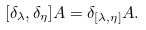<formula> <loc_0><loc_0><loc_500><loc_500>[ \delta _ { \lambda } , \delta _ { \eta } ] A = \delta _ { [ \lambda , \eta ] } A .</formula> 